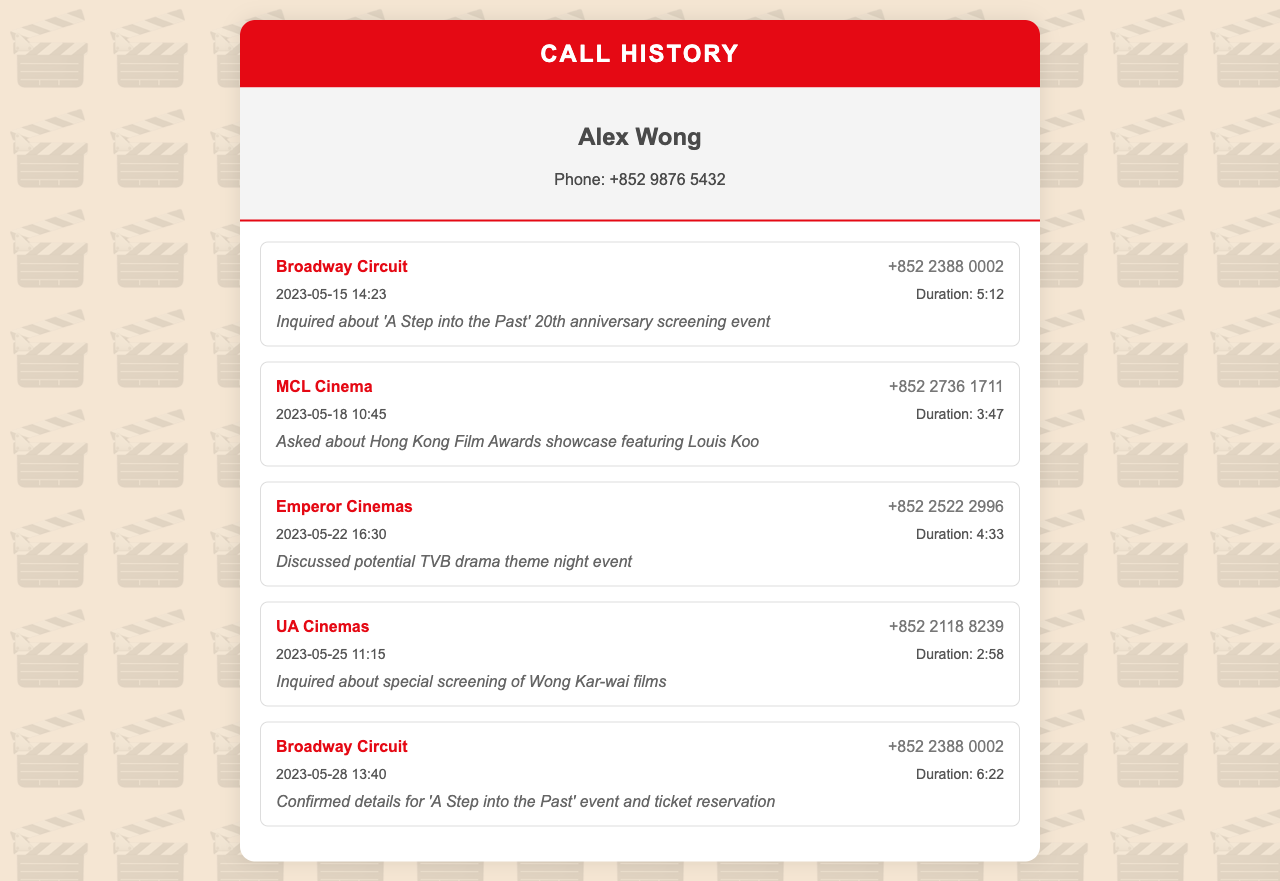What is the name of the caller? The name of the caller is located in the owner-info section of the document.
Answer: Alex Wong How many calls were made to Broadway Circuit? The calls to Broadway Circuit can be counted from the call list.
Answer: 2 What was the duration of the call to MCL Cinema? The duration is provided in the call details for MCL Cinema.
Answer: 3:47 Which cinema was contacted about Wong Kar-wai films? The contact information includes calls related to specific films, showing who was inquired.
Answer: UA Cinemas When was the last call made? The date and time of the last call can be determined from the call list.
Answer: 2023-05-28 13:40 What event was inquired about on May 15? The call notes detail the specific inquiries made in each call.
Answer: A Step into the Past 20th anniversary screening event How many total calls are listed in the document? The total calls can be computed by counting each call item in the call list.
Answer: 5 What is the phone number of Emperor Cinemas? The phone number can be found directly next to the cinema's name in the call list.
Answer: +852 2522 2996 What was discussed during the call to MCL Cinema? The call notes summarize the topics discussed in each call.
Answer: Hong Kong Film Awards showcase featuring Louis Koo 